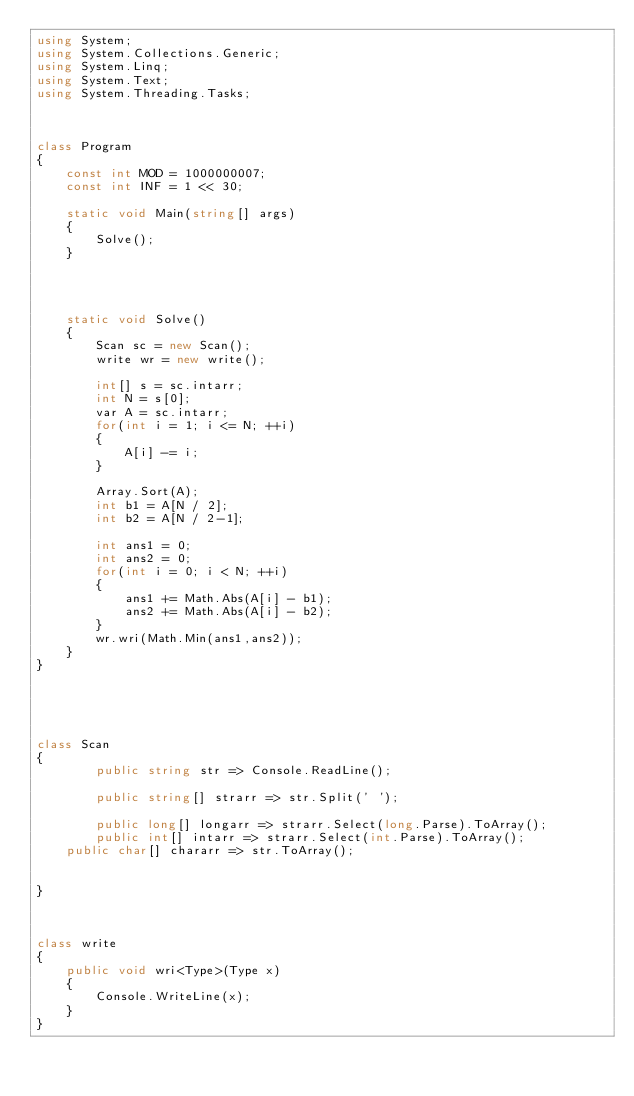Convert code to text. <code><loc_0><loc_0><loc_500><loc_500><_C#_>using System;
using System.Collections.Generic;
using System.Linq;
using System.Text;
using System.Threading.Tasks;



class Program
{
    const int MOD = 1000000007;
    const int INF = 1 << 30;

    static void Main(string[] args)
    {
        Solve();
    }




    static void Solve()
    {
        Scan sc = new Scan();
        write wr = new write();

        int[] s = sc.intarr;
        int N = s[0];
        var A = sc.intarr;
        for(int i = 1; i <= N; ++i)
        {
            A[i] -= i;
        }

        Array.Sort(A);
        int b1 = A[N / 2];
        int b2 = A[N / 2-1];

        int ans1 = 0;
        int ans2 = 0;
        for(int i = 0; i < N; ++i)
        {
            ans1 += Math.Abs(A[i] - b1);
            ans2 += Math.Abs(A[i] - b2);
        }
        wr.wri(Math.Min(ans1,ans2));
    }
}
    




class Scan
{
        public string str => Console.ReadLine();

        public string[] strarr => str.Split(' ');

        public long[] longarr => strarr.Select(long.Parse).ToArray();
        public int[] intarr => strarr.Select(int.Parse).ToArray();
    public char[] chararr => str.ToArray();


}



class write
{
    public void wri<Type>(Type x)
    {
        Console.WriteLine(x);
    }
}
</code> 